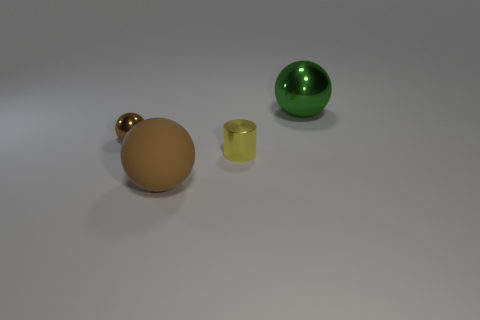There is a small thing that is the same shape as the big matte thing; what is its color?
Offer a very short reply. Brown. There is a ball that is both on the left side of the tiny yellow cylinder and behind the large brown object; what material is it?
Offer a very short reply. Metal. There is a shiny object to the right of the cylinder; does it have the same size as the small brown metal sphere?
Provide a short and direct response. No. What is the material of the small yellow cylinder?
Offer a terse response. Metal. What is the color of the shiny thing behind the brown metallic object?
Offer a terse response. Green. How many large things are either brown balls or purple matte cubes?
Your response must be concise. 1. There is a shiny sphere behind the tiny brown metallic object; is it the same color as the small shiny thing that is to the left of the brown rubber ball?
Offer a terse response. No. What number of other things are the same color as the matte ball?
Your answer should be compact. 1. What number of green objects are either big things or balls?
Ensure brevity in your answer.  1. Do the large green object and the brown thing to the left of the matte sphere have the same shape?
Give a very brief answer. Yes. 